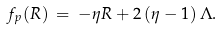Convert formula to latex. <formula><loc_0><loc_0><loc_500><loc_500>f _ { p } ( R ) \, = \, - \eta R + 2 \left ( \eta - 1 \right ) \Lambda .</formula> 